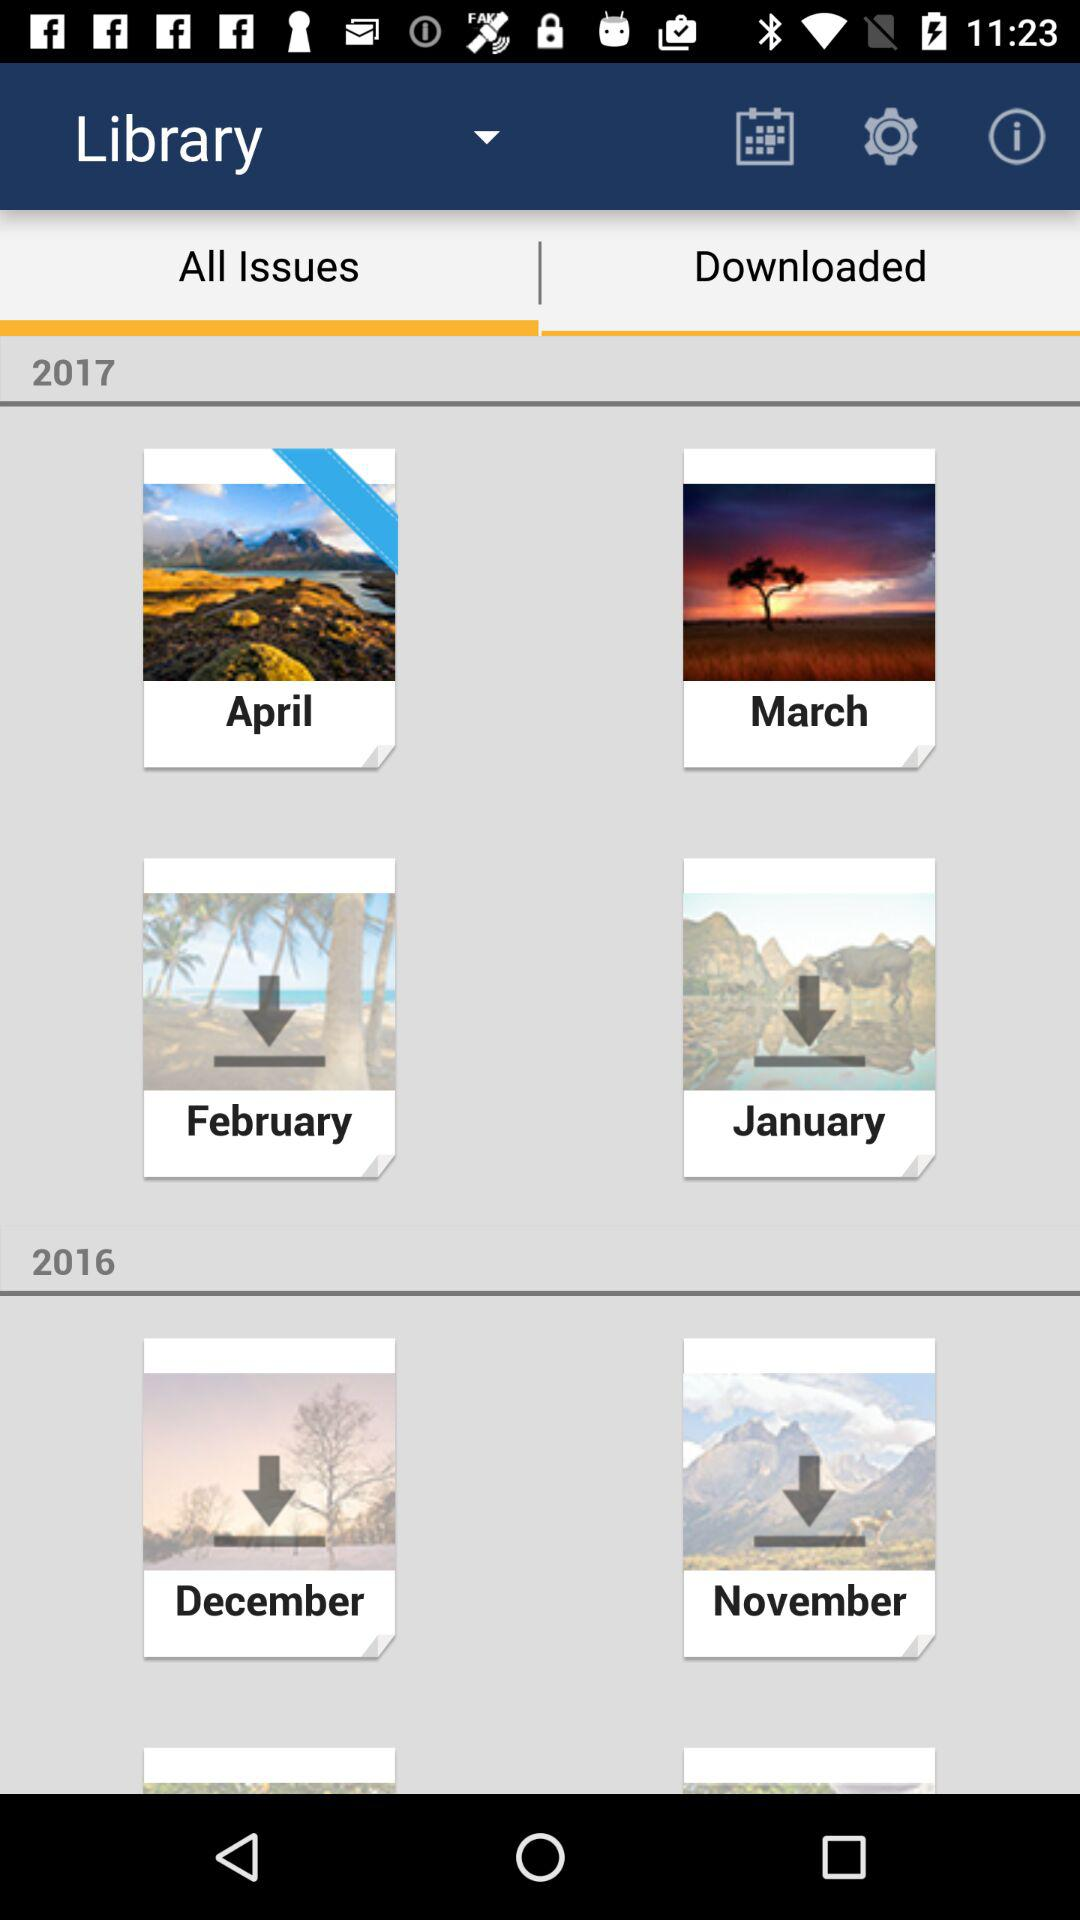Which months of the calendar are given in 2017? The given months of the calendar are April, March, February and January. 